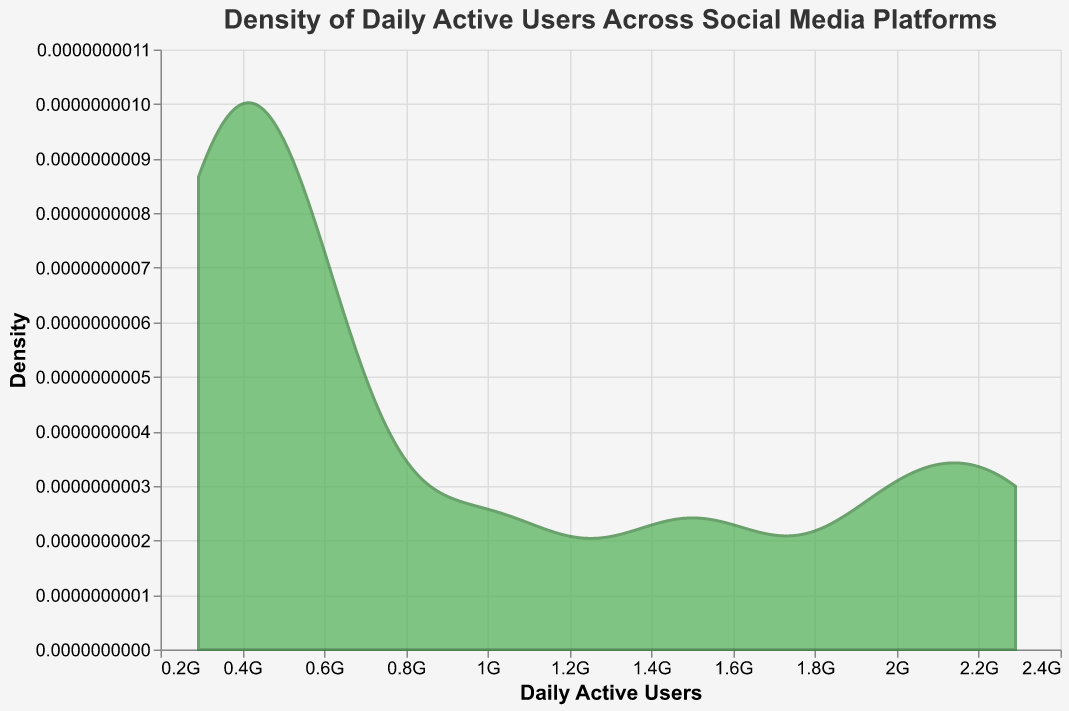What is the title of the figure? The title of the figure is usually located at the top of the plot in a bigger font size. Here, it states "Density of Daily Active Users Across Social Media Platforms."
Answer: Density of Daily Active Users Across Social Media Platforms What platforms are included in the analysis? From the data provided and the labels on the x-axis, the platforms included are Facebook, Instagram, Twitter, LinkedIn, Snapchat, Pinterest, Reddit, TikTok, and YouTube.
Answer: Facebook, Instagram, Twitter, LinkedIn, Snapchat, Pinterest, Reddit, TikTok, YouTube What is the range of Daily Active Users covered in the plot? The x-axis represents daily active users, showcasing values from the minimum to the maximum in the dataset. Examining this range shows daily active users between 293 million and 2.29 billion.
Answer: 293 million to 2.29 billion Which platform has the highest daily active users, according to the plot? By looking at the extreme right side of the density curve, corresponding to the maximum number on the x-axis, Facebook has the highest daily active users at 2.29 billion.
Answer: Facebook What is the density value associated with 1 billion daily active users? To find the density for 1 billion daily active users, one must follow the curve from the 1 billion mark along the x-axis up to the corresponding y-axis value.
Answer: Approximately 0.000000001 Is there a clear peak in the density plot? If so, around what value does it occur? Observing the highest point of the curve will indicate where the density is maximum. The peak seems to occur around the 450 million to 600 million daily active users range, considering the visible distribution shape.
Answer: Around 450-600 million What is the color and opacity of the area representing the density plot? The visual characteristics of the density plot are indicated by the filled area. It is colored in a shade of green with an opacity of 0.7.
Answer: Green with opacity of 0.7 How many platforms have daily active users fewer than 500 million? By examining the data points on the x-axis and matching them to their corresponding platforms, 5 platforms—Twitter, LinkedIn, Snapchat, Pinterest, and Reddit—have fewer than 500 million daily active users.
Answer: 5 platforms Which platform has slightly more than 1.5 billion daily active users, as per the plot? The value just above 1.5 billion along the x-axis corresponds to Instagram from the provided data points.
Answer: Instagram Does the density plot show a bimodal distribution? A bimodal distribution would have two distinct peaks. Observing the plot, it is not explicitly bimodal, as it shows one main peak and possibly minor variations but not two distinct and separate peaks.
Answer: No 